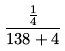Convert formula to latex. <formula><loc_0><loc_0><loc_500><loc_500>\frac { \frac { 1 } { 4 } } { 1 3 8 + 4 }</formula> 